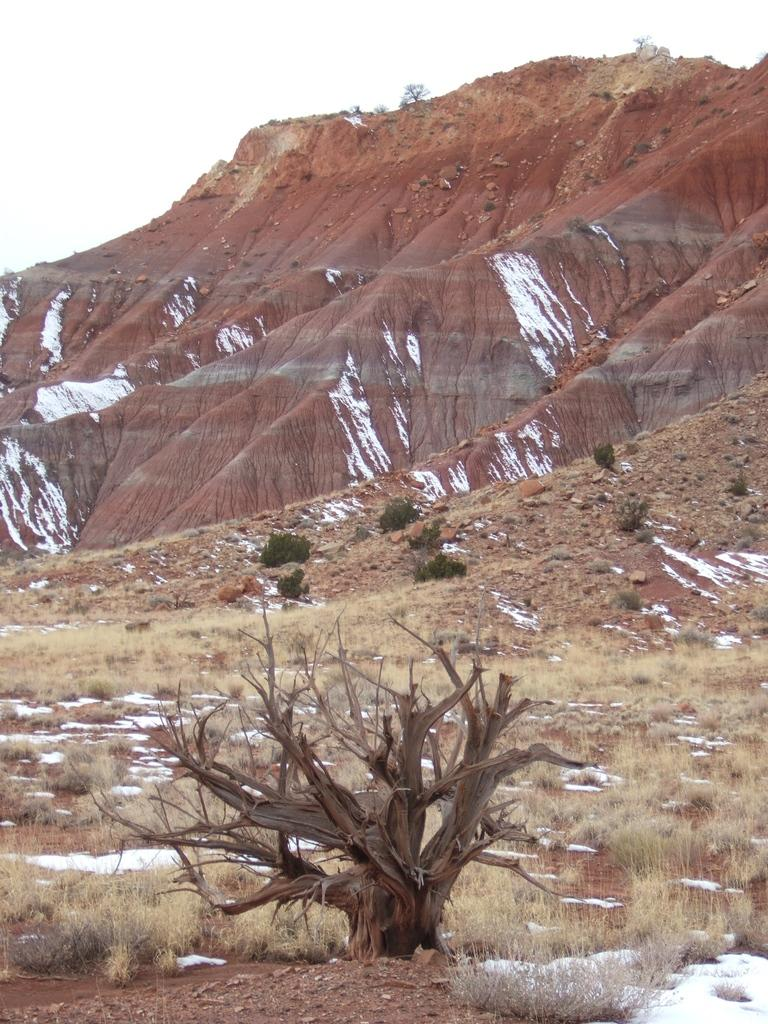What is the main subject in the center of the image? There is a tree in the center of the image. What type of vegetation can be seen in the image? There is grass and plants visible in the image. What is the weather like in the image? There is snow in the image, which suggests a cold or wintery environment. What is visible in the background of the image? There is sky, clouds, and a hill visible in the background of the image. What type of attraction is present in the image? There is no attraction present in the image; it features a tree, grass, plants, snow, and a hill in the background. Can you see the pet playing in the image? There is no pet present in the image. 